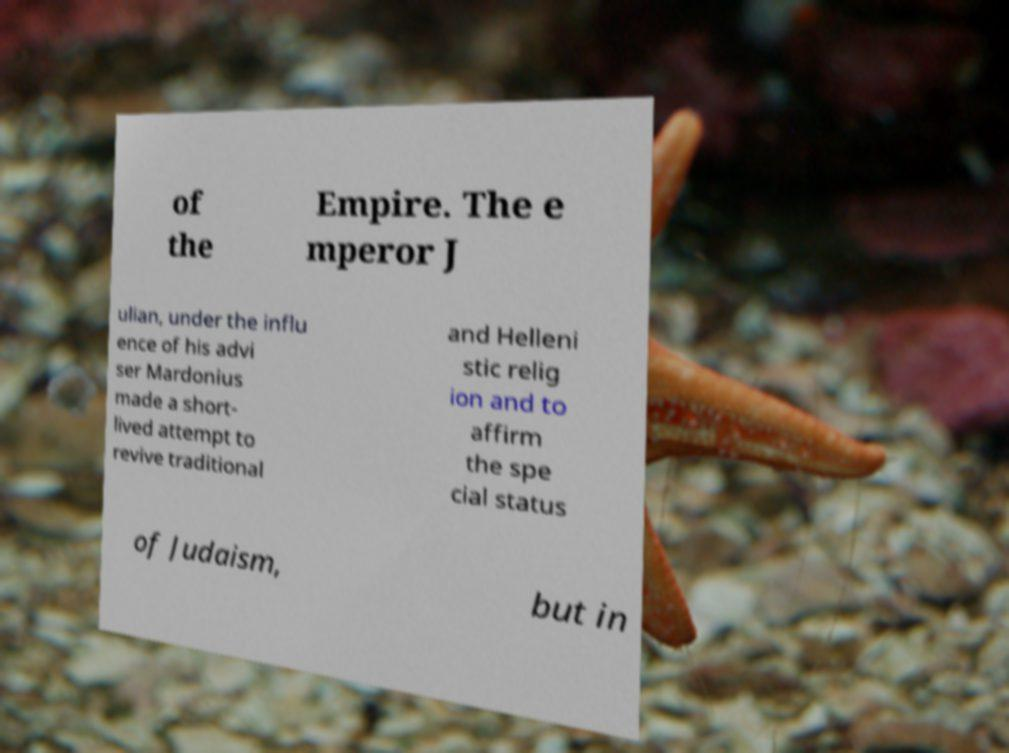I need the written content from this picture converted into text. Can you do that? of the Empire. The e mperor J ulian, under the influ ence of his advi ser Mardonius made a short- lived attempt to revive traditional and Helleni stic relig ion and to affirm the spe cial status of Judaism, but in 